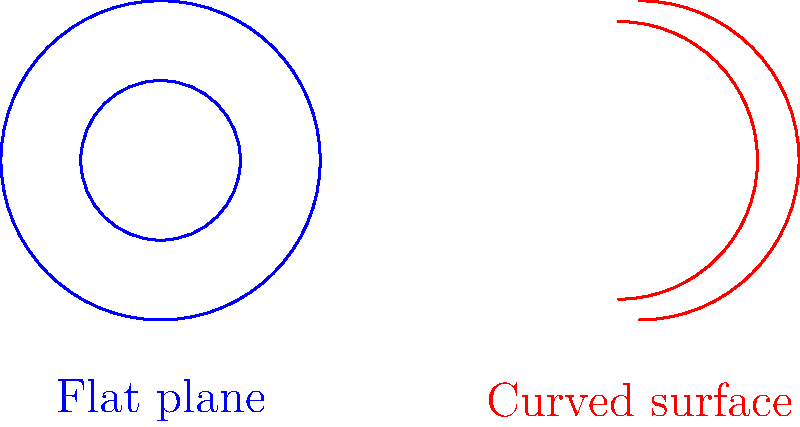In the context of Confederate statues, understanding different perspectives is crucial. Similarly, in geometry, perspective changes how we view shapes. The image shows circles on a flat plane and a curved surface. How does the behavior of circles differ on these surfaces, and how might this relate to viewing historical monuments from different angles? 1. On a flat plane (Euclidean geometry):
   - Circles maintain constant curvature.
   - The ratio of a circle's circumference to its diameter is always $\pi$.
   - Parallel lines never intersect.

2. On a curved surface (Non-Euclidean geometry):
   - Circles appear distorted and have varying curvature.
   - The ratio of a circle's circumference to its diameter is less than $\pi$.
   - Parallel lines can intersect.

3. Relating to Confederate statues:
   - Flat plane: Viewing history from a single, unchanging perspective.
   - Curved surface: Acknowledging multiple viewpoints and complexities in historical narratives.

4. The curved surface represents:
   - The multifaceted nature of historical events.
   - The importance of context in interpreting monuments.
   - The need for a nuanced approach to controversial topics.

5. Just as circles behave differently on curved surfaces, interpretations of Confederate statues can vary based on different historical and cultural perspectives.
Answer: Circles on curved surfaces have varying curvature and circumference-to-diameter ratios less than $\pi$, symbolizing the need for multiple perspectives in interpreting controversial monuments. 